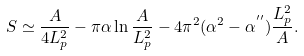<formula> <loc_0><loc_0><loc_500><loc_500>S \simeq \frac { A } { 4 L _ { p } ^ { 2 } } - \pi \alpha \ln \frac { A } { L _ { p } ^ { 2 } } - 4 \pi ^ { 2 } ( \alpha ^ { 2 } - \alpha ^ { ^ { \prime \prime } } ) \frac { L _ { p } ^ { 2 } } { A } .</formula> 